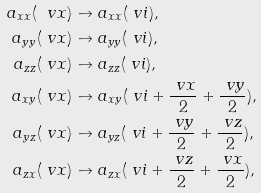<formula> <loc_0><loc_0><loc_500><loc_500>a _ { x x } ( \ v x ) & \to a _ { x x } ( \ v i ) , \\ a _ { y y } ( \ v x ) & \to a _ { y y } ( \ v i ) , \\ a _ { z z } ( \ v x ) & \to a _ { z z } ( \ v i ) , \\ a _ { x y } ( \ v x ) & \to a _ { x y } ( \ v i + \frac { \ v x } { 2 } + \frac { \ v y } { 2 } ) , \\ a _ { y z } ( \ v x ) & \to a _ { y z } ( \ v i + \frac { \ v y } { 2 } + \frac { \ v z } { 2 } ) , \\ a _ { z x } ( \ v x ) & \to a _ { z x } ( \ v i + \frac { \ v z } { 2 } + \frac { \ v x } { 2 } ) ,</formula> 